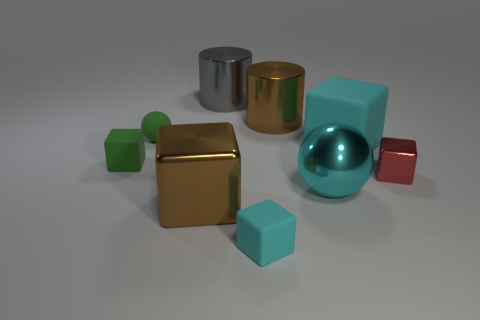Subtract all big brown blocks. How many blocks are left? 4 Subtract all green blocks. How many blocks are left? 4 Subtract 2 spheres. How many spheres are left? 0 Add 1 large cyan spheres. How many objects exist? 10 Subtract all spheres. How many objects are left? 7 Add 7 green matte spheres. How many green matte spheres are left? 8 Add 7 large cyan blocks. How many large cyan blocks exist? 8 Subtract 1 cyan balls. How many objects are left? 8 Subtract all yellow cubes. Subtract all green spheres. How many cubes are left? 5 Subtract all cyan spheres. How many purple cubes are left? 0 